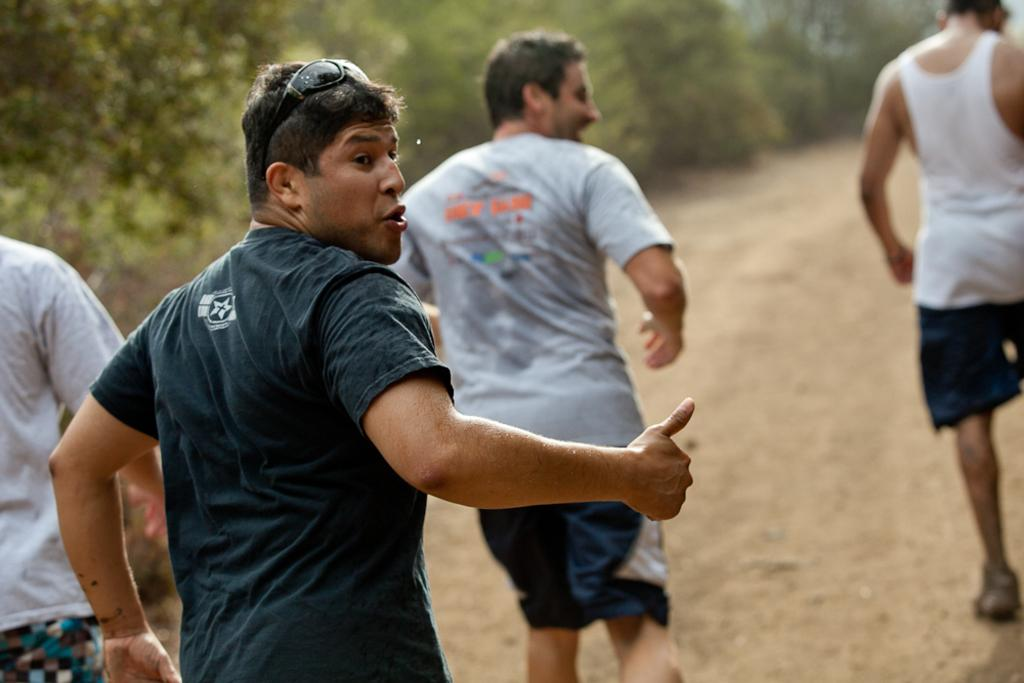What is the main subject of the image? The main subject of the image is a man. What is the man wearing on his face? The man is wearing goggles. What type of clothing is the man wearing on his upper body? The man is wearing a t-shirt. How many people are in front of the man? There are three persons in front of the man. What are the three persons doing in the image? The three persons are running on the ground. What can be seen in the background of the image? There are many trees in the background of the image. What type of fowl can be seen flying in the image? There is no fowl visible in the image; the focus is on the man and the three persons running. What is the name of the show that the man is participating in? The image does not provide any information about a show or any context that would suggest the man is participating in one. 